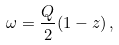Convert formula to latex. <formula><loc_0><loc_0><loc_500><loc_500>\omega = \frac { Q } { 2 } ( 1 - z ) \, ,</formula> 